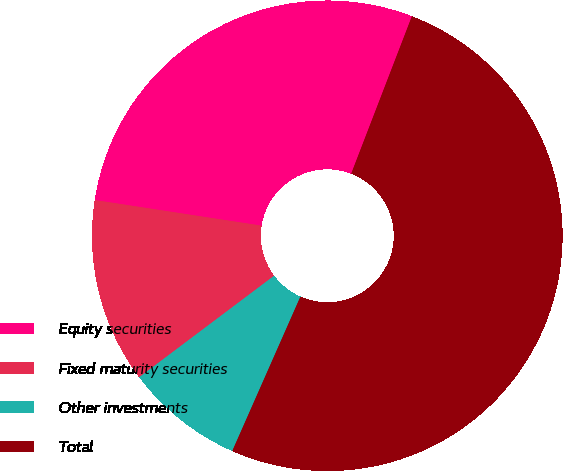Convert chart. <chart><loc_0><loc_0><loc_500><loc_500><pie_chart><fcel>Equity securities<fcel>Fixed maturity securities<fcel>Other investments<fcel>Total<nl><fcel>28.43%<fcel>12.69%<fcel>8.12%<fcel>50.76%<nl></chart> 